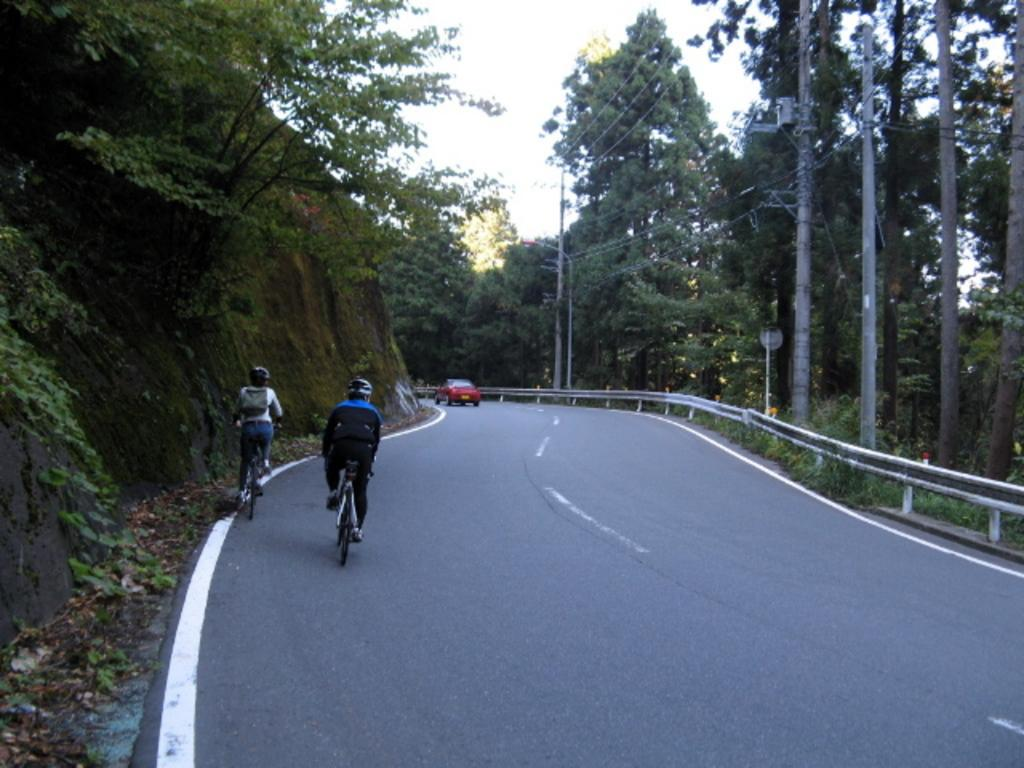How many people are riding the bicycle in the image? There are two people riding the bicycle in the image. What safety precaution are the people taking while riding the bicycle? The people are wearing helmets. What can be seen in the background of the image? There is a car, trees, poles, plants, wires, and the sky visible in the background of the image. What type of jam is being spread on the ornament in the image? There is no jam or ornament present in the image. 